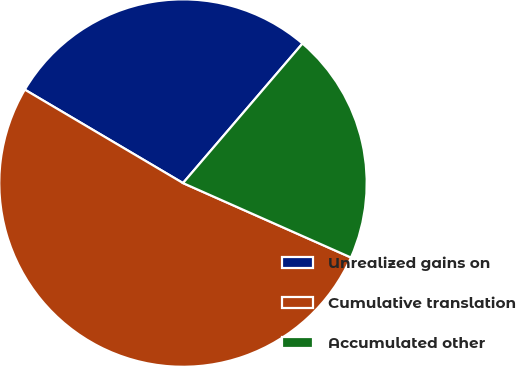Convert chart. <chart><loc_0><loc_0><loc_500><loc_500><pie_chart><fcel>Unrealized gains on<fcel>Cumulative translation<fcel>Accumulated other<nl><fcel>27.78%<fcel>51.85%<fcel>20.37%<nl></chart> 